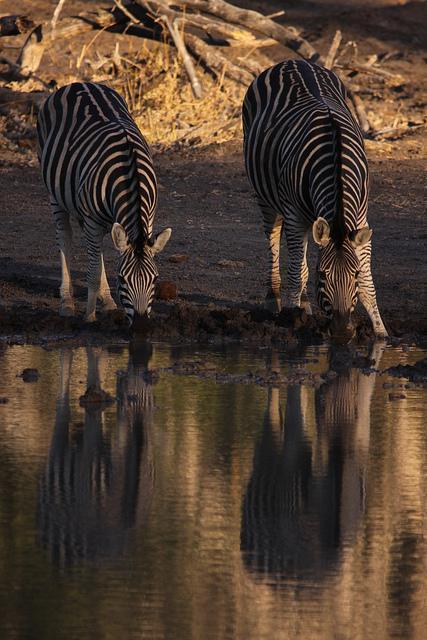How many zebras are there?
Give a very brief answer. 2. How many large bags is the old man holding?
Give a very brief answer. 0. 